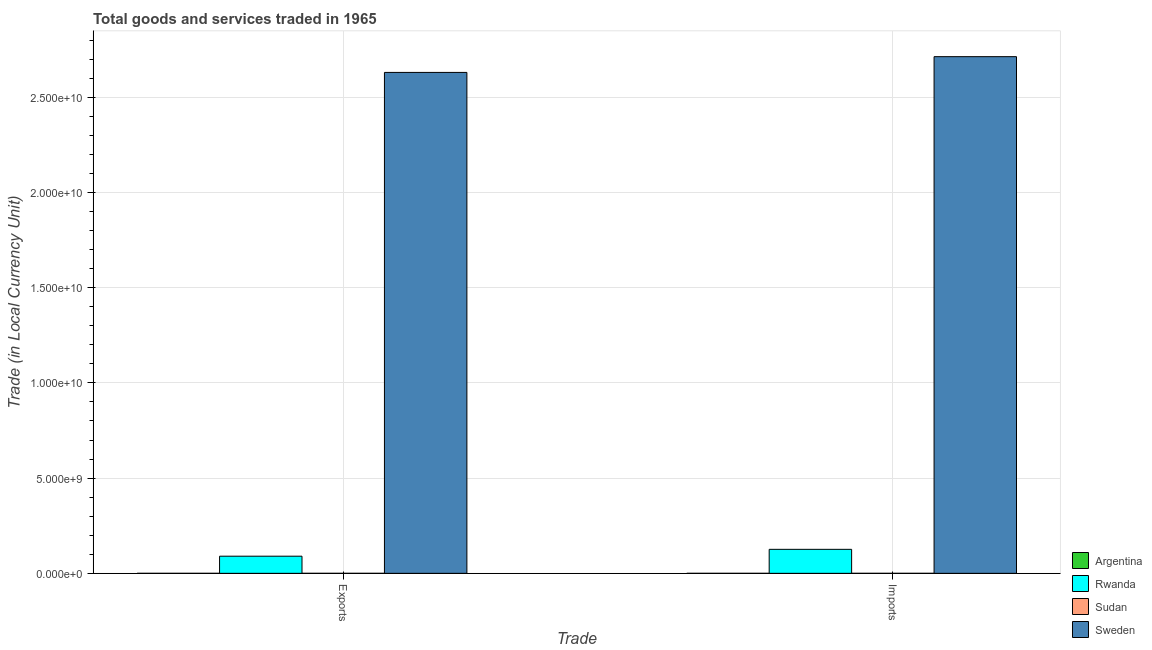How many different coloured bars are there?
Your answer should be very brief. 4. Are the number of bars on each tick of the X-axis equal?
Make the answer very short. Yes. How many bars are there on the 1st tick from the left?
Your response must be concise. 4. How many bars are there on the 2nd tick from the right?
Provide a succinct answer. 4. What is the label of the 2nd group of bars from the left?
Your response must be concise. Imports. What is the export of goods and services in Sweden?
Your answer should be very brief. 2.63e+1. Across all countries, what is the maximum imports of goods and services?
Your response must be concise. 2.71e+1. Across all countries, what is the minimum export of goods and services?
Your response must be concise. 0.03. What is the total export of goods and services in the graph?
Provide a short and direct response. 2.72e+1. What is the difference between the export of goods and services in Rwanda and that in Sudan?
Provide a succinct answer. 9.00e+08. What is the difference between the export of goods and services in Argentina and the imports of goods and services in Sudan?
Give a very brief answer. -7.58e+04. What is the average export of goods and services per country?
Make the answer very short. 6.80e+09. What is the difference between the imports of goods and services and export of goods and services in Rwanda?
Offer a terse response. 3.60e+08. What is the ratio of the imports of goods and services in Sudan to that in Rwanda?
Ensure brevity in your answer.  6.015873015873016e-5. What does the 1st bar from the right in Imports represents?
Provide a succinct answer. Sweden. How many bars are there?
Your answer should be very brief. 8. Are all the bars in the graph horizontal?
Offer a very short reply. No. Are the values on the major ticks of Y-axis written in scientific E-notation?
Provide a succinct answer. Yes. Does the graph contain any zero values?
Your response must be concise. No. Does the graph contain grids?
Give a very brief answer. Yes. How many legend labels are there?
Make the answer very short. 4. How are the legend labels stacked?
Offer a very short reply. Vertical. What is the title of the graph?
Provide a succinct answer. Total goods and services traded in 1965. What is the label or title of the X-axis?
Provide a short and direct response. Trade. What is the label or title of the Y-axis?
Offer a very short reply. Trade (in Local Currency Unit). What is the Trade (in Local Currency Unit) in Argentina in Exports?
Provide a short and direct response. 0.03. What is the Trade (in Local Currency Unit) of Rwanda in Exports?
Your response must be concise. 9.00e+08. What is the Trade (in Local Currency Unit) of Sudan in Exports?
Your answer should be compact. 7.17e+04. What is the Trade (in Local Currency Unit) in Sweden in Exports?
Ensure brevity in your answer.  2.63e+1. What is the Trade (in Local Currency Unit) of Argentina in Imports?
Make the answer very short. 0.02. What is the Trade (in Local Currency Unit) in Rwanda in Imports?
Give a very brief answer. 1.26e+09. What is the Trade (in Local Currency Unit) of Sudan in Imports?
Offer a very short reply. 7.58e+04. What is the Trade (in Local Currency Unit) in Sweden in Imports?
Keep it short and to the point. 2.71e+1. Across all Trade, what is the maximum Trade (in Local Currency Unit) of Argentina?
Give a very brief answer. 0.03. Across all Trade, what is the maximum Trade (in Local Currency Unit) in Rwanda?
Give a very brief answer. 1.26e+09. Across all Trade, what is the maximum Trade (in Local Currency Unit) in Sudan?
Ensure brevity in your answer.  7.58e+04. Across all Trade, what is the maximum Trade (in Local Currency Unit) of Sweden?
Keep it short and to the point. 2.71e+1. Across all Trade, what is the minimum Trade (in Local Currency Unit) in Argentina?
Your answer should be very brief. 0.02. Across all Trade, what is the minimum Trade (in Local Currency Unit) of Rwanda?
Keep it short and to the point. 9.00e+08. Across all Trade, what is the minimum Trade (in Local Currency Unit) of Sudan?
Offer a very short reply. 7.17e+04. Across all Trade, what is the minimum Trade (in Local Currency Unit) of Sweden?
Offer a very short reply. 2.63e+1. What is the total Trade (in Local Currency Unit) in Argentina in the graph?
Keep it short and to the point. 0.05. What is the total Trade (in Local Currency Unit) of Rwanda in the graph?
Keep it short and to the point. 2.16e+09. What is the total Trade (in Local Currency Unit) in Sudan in the graph?
Your answer should be compact. 1.48e+05. What is the total Trade (in Local Currency Unit) in Sweden in the graph?
Provide a short and direct response. 5.34e+1. What is the difference between the Trade (in Local Currency Unit) in Rwanda in Exports and that in Imports?
Make the answer very short. -3.60e+08. What is the difference between the Trade (in Local Currency Unit) in Sudan in Exports and that in Imports?
Your answer should be compact. -4100. What is the difference between the Trade (in Local Currency Unit) in Sweden in Exports and that in Imports?
Ensure brevity in your answer.  -8.27e+08. What is the difference between the Trade (in Local Currency Unit) of Argentina in Exports and the Trade (in Local Currency Unit) of Rwanda in Imports?
Offer a terse response. -1.26e+09. What is the difference between the Trade (in Local Currency Unit) in Argentina in Exports and the Trade (in Local Currency Unit) in Sudan in Imports?
Your answer should be compact. -7.58e+04. What is the difference between the Trade (in Local Currency Unit) in Argentina in Exports and the Trade (in Local Currency Unit) in Sweden in Imports?
Provide a succinct answer. -2.71e+1. What is the difference between the Trade (in Local Currency Unit) of Rwanda in Exports and the Trade (in Local Currency Unit) of Sudan in Imports?
Make the answer very short. 9.00e+08. What is the difference between the Trade (in Local Currency Unit) of Rwanda in Exports and the Trade (in Local Currency Unit) of Sweden in Imports?
Provide a short and direct response. -2.62e+1. What is the difference between the Trade (in Local Currency Unit) in Sudan in Exports and the Trade (in Local Currency Unit) in Sweden in Imports?
Make the answer very short. -2.71e+1. What is the average Trade (in Local Currency Unit) of Argentina per Trade?
Give a very brief answer. 0.03. What is the average Trade (in Local Currency Unit) in Rwanda per Trade?
Offer a very short reply. 1.08e+09. What is the average Trade (in Local Currency Unit) in Sudan per Trade?
Your answer should be compact. 7.38e+04. What is the average Trade (in Local Currency Unit) in Sweden per Trade?
Give a very brief answer. 2.67e+1. What is the difference between the Trade (in Local Currency Unit) of Argentina and Trade (in Local Currency Unit) of Rwanda in Exports?
Offer a terse response. -9.00e+08. What is the difference between the Trade (in Local Currency Unit) of Argentina and Trade (in Local Currency Unit) of Sudan in Exports?
Offer a very short reply. -7.17e+04. What is the difference between the Trade (in Local Currency Unit) in Argentina and Trade (in Local Currency Unit) in Sweden in Exports?
Offer a terse response. -2.63e+1. What is the difference between the Trade (in Local Currency Unit) of Rwanda and Trade (in Local Currency Unit) of Sudan in Exports?
Provide a short and direct response. 9.00e+08. What is the difference between the Trade (in Local Currency Unit) of Rwanda and Trade (in Local Currency Unit) of Sweden in Exports?
Keep it short and to the point. -2.54e+1. What is the difference between the Trade (in Local Currency Unit) of Sudan and Trade (in Local Currency Unit) of Sweden in Exports?
Your response must be concise. -2.63e+1. What is the difference between the Trade (in Local Currency Unit) in Argentina and Trade (in Local Currency Unit) in Rwanda in Imports?
Ensure brevity in your answer.  -1.26e+09. What is the difference between the Trade (in Local Currency Unit) in Argentina and Trade (in Local Currency Unit) in Sudan in Imports?
Offer a very short reply. -7.58e+04. What is the difference between the Trade (in Local Currency Unit) in Argentina and Trade (in Local Currency Unit) in Sweden in Imports?
Your answer should be very brief. -2.71e+1. What is the difference between the Trade (in Local Currency Unit) in Rwanda and Trade (in Local Currency Unit) in Sudan in Imports?
Your answer should be very brief. 1.26e+09. What is the difference between the Trade (in Local Currency Unit) in Rwanda and Trade (in Local Currency Unit) in Sweden in Imports?
Your answer should be compact. -2.59e+1. What is the difference between the Trade (in Local Currency Unit) of Sudan and Trade (in Local Currency Unit) of Sweden in Imports?
Give a very brief answer. -2.71e+1. What is the ratio of the Trade (in Local Currency Unit) of Rwanda in Exports to that in Imports?
Offer a very short reply. 0.71. What is the ratio of the Trade (in Local Currency Unit) in Sudan in Exports to that in Imports?
Make the answer very short. 0.95. What is the ratio of the Trade (in Local Currency Unit) of Sweden in Exports to that in Imports?
Ensure brevity in your answer.  0.97. What is the difference between the highest and the second highest Trade (in Local Currency Unit) of Rwanda?
Ensure brevity in your answer.  3.60e+08. What is the difference between the highest and the second highest Trade (in Local Currency Unit) in Sudan?
Your response must be concise. 4100. What is the difference between the highest and the second highest Trade (in Local Currency Unit) of Sweden?
Offer a terse response. 8.27e+08. What is the difference between the highest and the lowest Trade (in Local Currency Unit) of Argentina?
Keep it short and to the point. 0.01. What is the difference between the highest and the lowest Trade (in Local Currency Unit) of Rwanda?
Your answer should be compact. 3.60e+08. What is the difference between the highest and the lowest Trade (in Local Currency Unit) of Sudan?
Ensure brevity in your answer.  4100. What is the difference between the highest and the lowest Trade (in Local Currency Unit) of Sweden?
Offer a very short reply. 8.27e+08. 